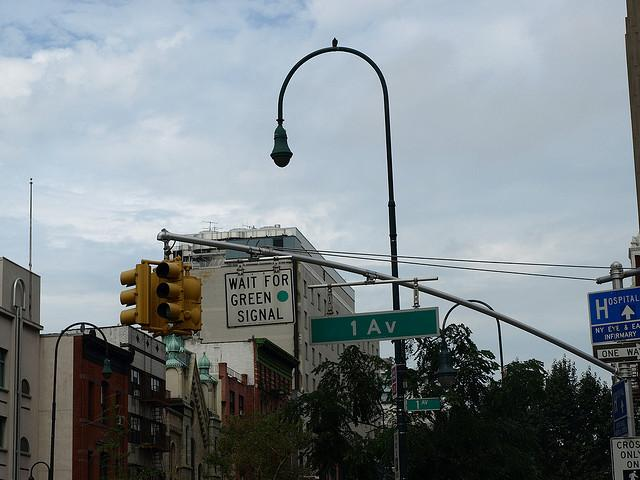What kind of environment is this?

Choices:
A) countryside
B) mountain vista
C) rural
D) urban urban 